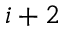<formula> <loc_0><loc_0><loc_500><loc_500>i + 2</formula> 